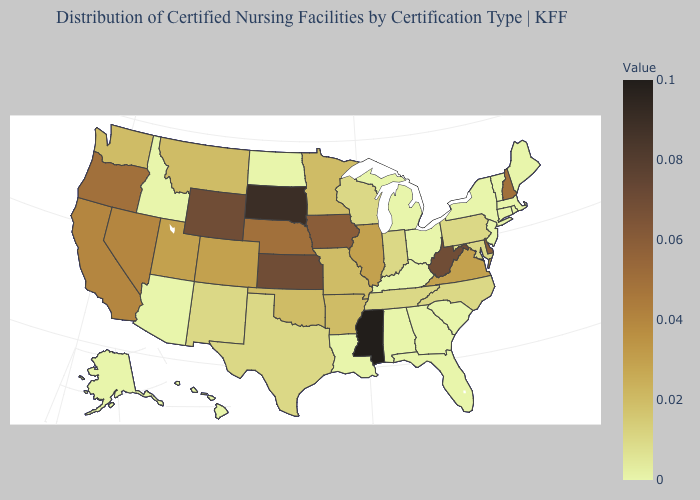Does Mississippi have the highest value in the USA?
Answer briefly. Yes. Among the states that border West Virginia , does Maryland have the highest value?
Keep it brief. No. Does Maine have the lowest value in the Northeast?
Answer briefly. Yes. 